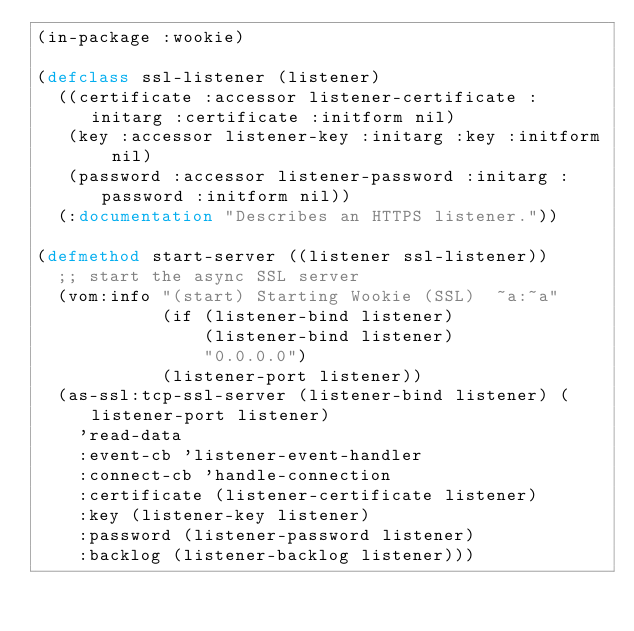<code> <loc_0><loc_0><loc_500><loc_500><_Lisp_>(in-package :wookie)

(defclass ssl-listener (listener)
  ((certificate :accessor listener-certificate :initarg :certificate :initform nil)
   (key :accessor listener-key :initarg :key :initform nil)
   (password :accessor listener-password :initarg :password :initform nil))
  (:documentation "Describes an HTTPS listener."))

(defmethod start-server ((listener ssl-listener))
  ;; start the async SSL server
  (vom:info "(start) Starting Wookie (SSL)  ~a:~a"
            (if (listener-bind listener)
                (listener-bind listener)
                "0.0.0.0")
            (listener-port listener))
  (as-ssl:tcp-ssl-server (listener-bind listener) (listener-port listener)
    'read-data
    :event-cb 'listener-event-handler
    :connect-cb 'handle-connection
    :certificate (listener-certificate listener)
    :key (listener-key listener)
    :password (listener-password listener)
    :backlog (listener-backlog listener)))

</code> 